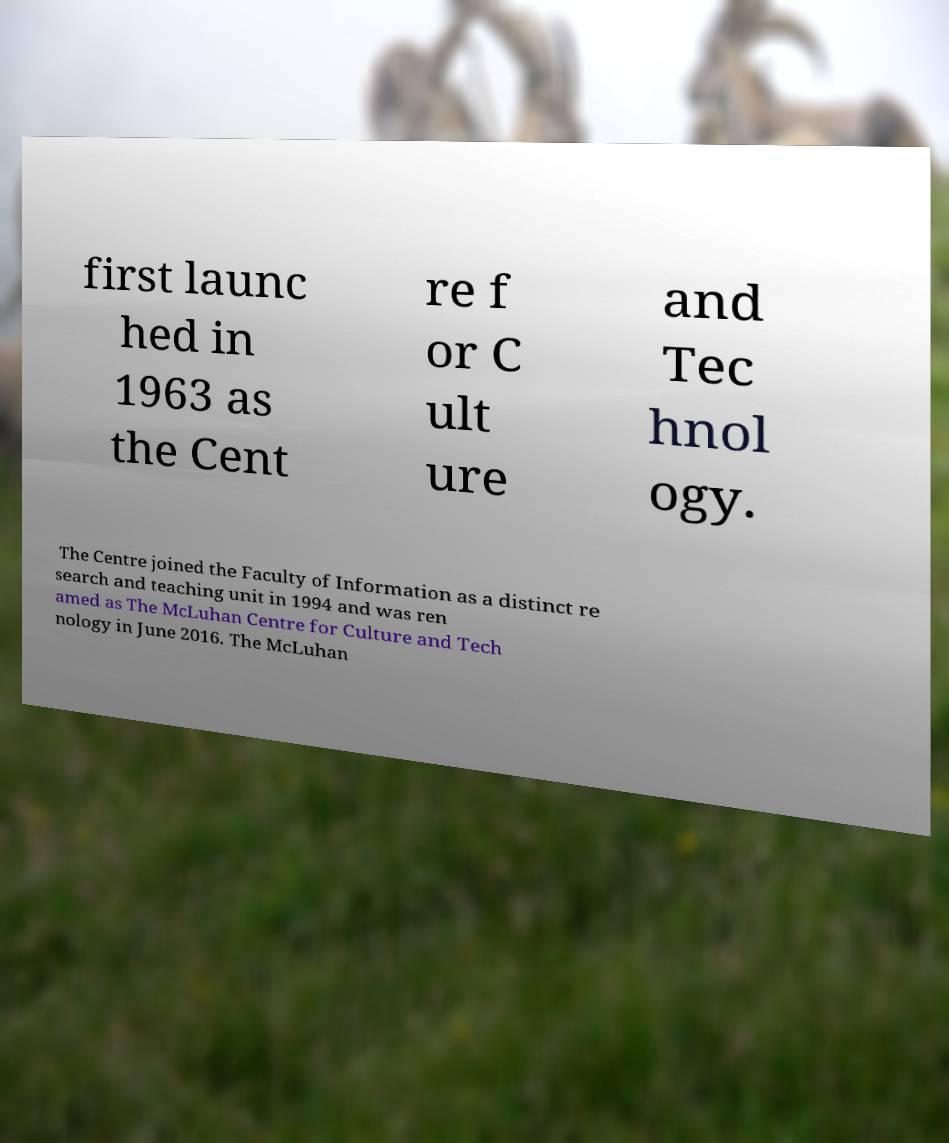There's text embedded in this image that I need extracted. Can you transcribe it verbatim? first launc hed in 1963 as the Cent re f or C ult ure and Tec hnol ogy. The Centre joined the Faculty of Information as a distinct re search and teaching unit in 1994 and was ren amed as The McLuhan Centre for Culture and Tech nology in June 2016. The McLuhan 